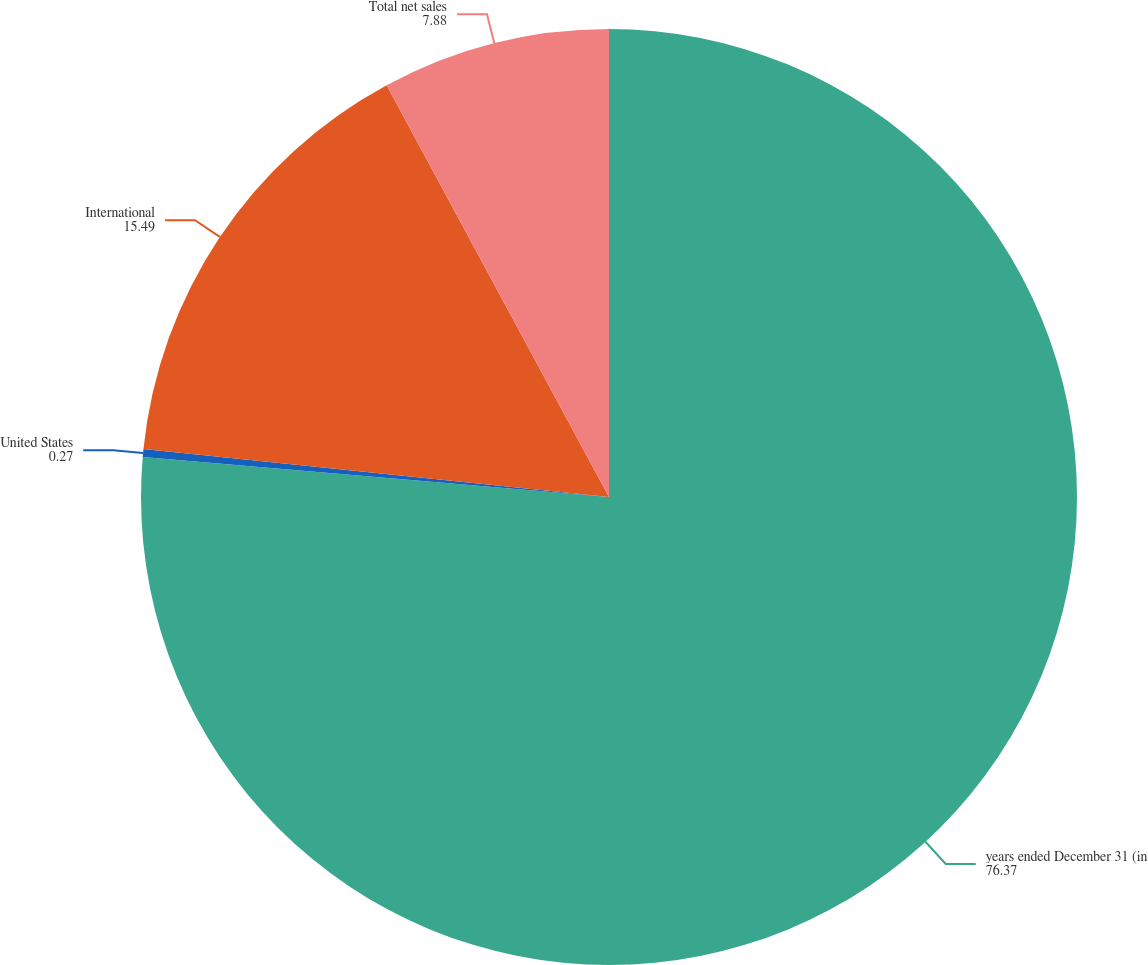Convert chart to OTSL. <chart><loc_0><loc_0><loc_500><loc_500><pie_chart><fcel>years ended December 31 (in<fcel>United States<fcel>International<fcel>Total net sales<nl><fcel>76.37%<fcel>0.27%<fcel>15.49%<fcel>7.88%<nl></chart> 